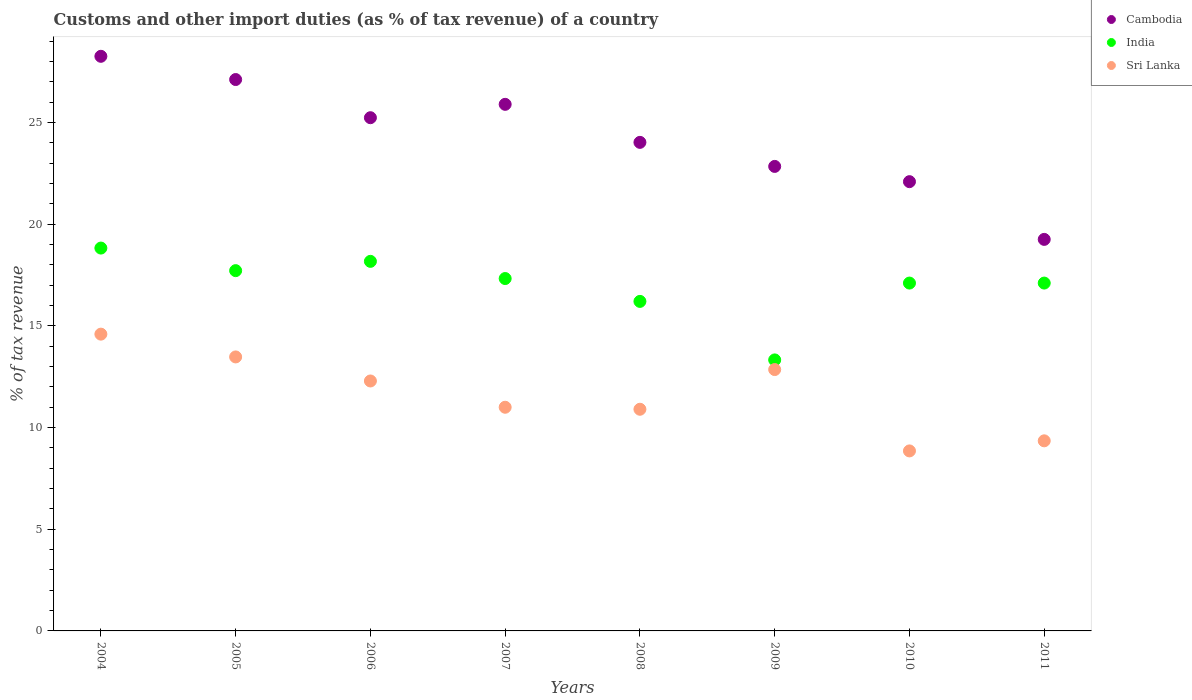What is the percentage of tax revenue from customs in Cambodia in 2008?
Offer a very short reply. 24.03. Across all years, what is the maximum percentage of tax revenue from customs in India?
Keep it short and to the point. 18.83. Across all years, what is the minimum percentage of tax revenue from customs in India?
Ensure brevity in your answer.  13.33. In which year was the percentage of tax revenue from customs in Sri Lanka maximum?
Give a very brief answer. 2004. What is the total percentage of tax revenue from customs in Sri Lanka in the graph?
Offer a very short reply. 93.32. What is the difference between the percentage of tax revenue from customs in Sri Lanka in 2005 and that in 2009?
Your answer should be compact. 0.62. What is the difference between the percentage of tax revenue from customs in India in 2006 and the percentage of tax revenue from customs in Sri Lanka in 2008?
Keep it short and to the point. 7.27. What is the average percentage of tax revenue from customs in India per year?
Your response must be concise. 16.98. In the year 2004, what is the difference between the percentage of tax revenue from customs in Sri Lanka and percentage of tax revenue from customs in India?
Your response must be concise. -4.23. In how many years, is the percentage of tax revenue from customs in India greater than 28 %?
Your answer should be very brief. 0. What is the ratio of the percentage of tax revenue from customs in Sri Lanka in 2004 to that in 2008?
Your answer should be very brief. 1.34. Is the percentage of tax revenue from customs in Cambodia in 2008 less than that in 2011?
Offer a terse response. No. Is the difference between the percentage of tax revenue from customs in Sri Lanka in 2004 and 2005 greater than the difference between the percentage of tax revenue from customs in India in 2004 and 2005?
Offer a terse response. Yes. What is the difference between the highest and the second highest percentage of tax revenue from customs in Sri Lanka?
Give a very brief answer. 1.12. What is the difference between the highest and the lowest percentage of tax revenue from customs in Sri Lanka?
Your response must be concise. 5.74. In how many years, is the percentage of tax revenue from customs in India greater than the average percentage of tax revenue from customs in India taken over all years?
Keep it short and to the point. 6. Is the sum of the percentage of tax revenue from customs in Cambodia in 2010 and 2011 greater than the maximum percentage of tax revenue from customs in Sri Lanka across all years?
Your answer should be very brief. Yes. Is it the case that in every year, the sum of the percentage of tax revenue from customs in Cambodia and percentage of tax revenue from customs in India  is greater than the percentage of tax revenue from customs in Sri Lanka?
Ensure brevity in your answer.  Yes. Does the percentage of tax revenue from customs in Sri Lanka monotonically increase over the years?
Offer a terse response. No. Is the percentage of tax revenue from customs in Sri Lanka strictly less than the percentage of tax revenue from customs in Cambodia over the years?
Your answer should be very brief. Yes. How many years are there in the graph?
Your answer should be very brief. 8. What is the difference between two consecutive major ticks on the Y-axis?
Provide a succinct answer. 5. Are the values on the major ticks of Y-axis written in scientific E-notation?
Offer a terse response. No. Does the graph contain any zero values?
Offer a very short reply. No. Where does the legend appear in the graph?
Provide a short and direct response. Top right. How many legend labels are there?
Give a very brief answer. 3. How are the legend labels stacked?
Your response must be concise. Vertical. What is the title of the graph?
Give a very brief answer. Customs and other import duties (as % of tax revenue) of a country. Does "Guam" appear as one of the legend labels in the graph?
Give a very brief answer. No. What is the label or title of the Y-axis?
Provide a short and direct response. % of tax revenue. What is the % of tax revenue of Cambodia in 2004?
Keep it short and to the point. 28.26. What is the % of tax revenue of India in 2004?
Your answer should be very brief. 18.83. What is the % of tax revenue of Sri Lanka in 2004?
Provide a succinct answer. 14.6. What is the % of tax revenue of Cambodia in 2005?
Offer a very short reply. 27.12. What is the % of tax revenue in India in 2005?
Your answer should be very brief. 17.72. What is the % of tax revenue in Sri Lanka in 2005?
Offer a terse response. 13.48. What is the % of tax revenue of Cambodia in 2006?
Your response must be concise. 25.24. What is the % of tax revenue of India in 2006?
Ensure brevity in your answer.  18.18. What is the % of tax revenue of Sri Lanka in 2006?
Give a very brief answer. 12.29. What is the % of tax revenue of Cambodia in 2007?
Keep it short and to the point. 25.9. What is the % of tax revenue in India in 2007?
Ensure brevity in your answer.  17.33. What is the % of tax revenue of Sri Lanka in 2007?
Make the answer very short. 11. What is the % of tax revenue of Cambodia in 2008?
Offer a very short reply. 24.03. What is the % of tax revenue of India in 2008?
Your answer should be compact. 16.21. What is the % of tax revenue of Sri Lanka in 2008?
Provide a short and direct response. 10.9. What is the % of tax revenue in Cambodia in 2009?
Make the answer very short. 22.85. What is the % of tax revenue of India in 2009?
Your response must be concise. 13.33. What is the % of tax revenue of Sri Lanka in 2009?
Your answer should be compact. 12.85. What is the % of tax revenue in Cambodia in 2010?
Ensure brevity in your answer.  22.1. What is the % of tax revenue of India in 2010?
Your answer should be very brief. 17.11. What is the % of tax revenue in Sri Lanka in 2010?
Offer a terse response. 8.85. What is the % of tax revenue in Cambodia in 2011?
Offer a very short reply. 19.26. What is the % of tax revenue of India in 2011?
Ensure brevity in your answer.  17.11. What is the % of tax revenue in Sri Lanka in 2011?
Keep it short and to the point. 9.35. Across all years, what is the maximum % of tax revenue of Cambodia?
Your answer should be compact. 28.26. Across all years, what is the maximum % of tax revenue in India?
Provide a short and direct response. 18.83. Across all years, what is the maximum % of tax revenue in Sri Lanka?
Provide a short and direct response. 14.6. Across all years, what is the minimum % of tax revenue in Cambodia?
Your answer should be very brief. 19.26. Across all years, what is the minimum % of tax revenue in India?
Offer a very short reply. 13.33. Across all years, what is the minimum % of tax revenue in Sri Lanka?
Provide a succinct answer. 8.85. What is the total % of tax revenue of Cambodia in the graph?
Ensure brevity in your answer.  194.75. What is the total % of tax revenue in India in the graph?
Give a very brief answer. 135.81. What is the total % of tax revenue in Sri Lanka in the graph?
Your answer should be very brief. 93.32. What is the difference between the % of tax revenue of Cambodia in 2004 and that in 2005?
Provide a succinct answer. 1.14. What is the difference between the % of tax revenue in India in 2004 and that in 2005?
Your response must be concise. 1.11. What is the difference between the % of tax revenue of Sri Lanka in 2004 and that in 2005?
Your answer should be compact. 1.12. What is the difference between the % of tax revenue in Cambodia in 2004 and that in 2006?
Provide a succinct answer. 3.02. What is the difference between the % of tax revenue of India in 2004 and that in 2006?
Your response must be concise. 0.65. What is the difference between the % of tax revenue of Sri Lanka in 2004 and that in 2006?
Provide a succinct answer. 2.3. What is the difference between the % of tax revenue of Cambodia in 2004 and that in 2007?
Provide a short and direct response. 2.36. What is the difference between the % of tax revenue of India in 2004 and that in 2007?
Give a very brief answer. 1.5. What is the difference between the % of tax revenue of Sri Lanka in 2004 and that in 2007?
Offer a terse response. 3.6. What is the difference between the % of tax revenue of Cambodia in 2004 and that in 2008?
Your answer should be very brief. 4.23. What is the difference between the % of tax revenue in India in 2004 and that in 2008?
Offer a very short reply. 2.62. What is the difference between the % of tax revenue in Sri Lanka in 2004 and that in 2008?
Keep it short and to the point. 3.69. What is the difference between the % of tax revenue of Cambodia in 2004 and that in 2009?
Make the answer very short. 5.42. What is the difference between the % of tax revenue in India in 2004 and that in 2009?
Ensure brevity in your answer.  5.5. What is the difference between the % of tax revenue of Sri Lanka in 2004 and that in 2009?
Provide a succinct answer. 1.74. What is the difference between the % of tax revenue of Cambodia in 2004 and that in 2010?
Your answer should be very brief. 6.17. What is the difference between the % of tax revenue of India in 2004 and that in 2010?
Give a very brief answer. 1.72. What is the difference between the % of tax revenue in Sri Lanka in 2004 and that in 2010?
Offer a very short reply. 5.74. What is the difference between the % of tax revenue of Cambodia in 2004 and that in 2011?
Provide a short and direct response. 9. What is the difference between the % of tax revenue in India in 2004 and that in 2011?
Keep it short and to the point. 1.72. What is the difference between the % of tax revenue of Sri Lanka in 2004 and that in 2011?
Your answer should be compact. 5.25. What is the difference between the % of tax revenue of Cambodia in 2005 and that in 2006?
Keep it short and to the point. 1.88. What is the difference between the % of tax revenue in India in 2005 and that in 2006?
Give a very brief answer. -0.46. What is the difference between the % of tax revenue of Sri Lanka in 2005 and that in 2006?
Ensure brevity in your answer.  1.18. What is the difference between the % of tax revenue in Cambodia in 2005 and that in 2007?
Keep it short and to the point. 1.22. What is the difference between the % of tax revenue of India in 2005 and that in 2007?
Provide a succinct answer. 0.39. What is the difference between the % of tax revenue of Sri Lanka in 2005 and that in 2007?
Keep it short and to the point. 2.48. What is the difference between the % of tax revenue of Cambodia in 2005 and that in 2008?
Give a very brief answer. 3.09. What is the difference between the % of tax revenue of India in 2005 and that in 2008?
Offer a terse response. 1.51. What is the difference between the % of tax revenue of Sri Lanka in 2005 and that in 2008?
Your answer should be very brief. 2.57. What is the difference between the % of tax revenue of Cambodia in 2005 and that in 2009?
Offer a terse response. 4.27. What is the difference between the % of tax revenue of India in 2005 and that in 2009?
Provide a short and direct response. 4.39. What is the difference between the % of tax revenue in Sri Lanka in 2005 and that in 2009?
Offer a terse response. 0.62. What is the difference between the % of tax revenue in Cambodia in 2005 and that in 2010?
Ensure brevity in your answer.  5.02. What is the difference between the % of tax revenue in India in 2005 and that in 2010?
Make the answer very short. 0.61. What is the difference between the % of tax revenue in Sri Lanka in 2005 and that in 2010?
Your response must be concise. 4.62. What is the difference between the % of tax revenue in Cambodia in 2005 and that in 2011?
Provide a succinct answer. 7.86. What is the difference between the % of tax revenue of India in 2005 and that in 2011?
Make the answer very short. 0.61. What is the difference between the % of tax revenue of Sri Lanka in 2005 and that in 2011?
Provide a short and direct response. 4.13. What is the difference between the % of tax revenue of Cambodia in 2006 and that in 2007?
Offer a very short reply. -0.66. What is the difference between the % of tax revenue of India in 2006 and that in 2007?
Keep it short and to the point. 0.85. What is the difference between the % of tax revenue of Sri Lanka in 2006 and that in 2007?
Provide a succinct answer. 1.29. What is the difference between the % of tax revenue in Cambodia in 2006 and that in 2008?
Offer a terse response. 1.21. What is the difference between the % of tax revenue in India in 2006 and that in 2008?
Your answer should be very brief. 1.97. What is the difference between the % of tax revenue in Sri Lanka in 2006 and that in 2008?
Your response must be concise. 1.39. What is the difference between the % of tax revenue in Cambodia in 2006 and that in 2009?
Give a very brief answer. 2.4. What is the difference between the % of tax revenue in India in 2006 and that in 2009?
Ensure brevity in your answer.  4.85. What is the difference between the % of tax revenue of Sri Lanka in 2006 and that in 2009?
Offer a very short reply. -0.56. What is the difference between the % of tax revenue of Cambodia in 2006 and that in 2010?
Your response must be concise. 3.15. What is the difference between the % of tax revenue of India in 2006 and that in 2010?
Offer a very short reply. 1.07. What is the difference between the % of tax revenue in Sri Lanka in 2006 and that in 2010?
Keep it short and to the point. 3.44. What is the difference between the % of tax revenue of Cambodia in 2006 and that in 2011?
Your answer should be very brief. 5.98. What is the difference between the % of tax revenue in India in 2006 and that in 2011?
Give a very brief answer. 1.07. What is the difference between the % of tax revenue in Sri Lanka in 2006 and that in 2011?
Your response must be concise. 2.94. What is the difference between the % of tax revenue of Cambodia in 2007 and that in 2008?
Your answer should be compact. 1.87. What is the difference between the % of tax revenue of India in 2007 and that in 2008?
Your answer should be compact. 1.12. What is the difference between the % of tax revenue in Sri Lanka in 2007 and that in 2008?
Keep it short and to the point. 0.1. What is the difference between the % of tax revenue in Cambodia in 2007 and that in 2009?
Offer a terse response. 3.05. What is the difference between the % of tax revenue of India in 2007 and that in 2009?
Offer a very short reply. 4. What is the difference between the % of tax revenue in Sri Lanka in 2007 and that in 2009?
Ensure brevity in your answer.  -1.85. What is the difference between the % of tax revenue of Cambodia in 2007 and that in 2010?
Give a very brief answer. 3.8. What is the difference between the % of tax revenue in India in 2007 and that in 2010?
Your answer should be compact. 0.22. What is the difference between the % of tax revenue in Sri Lanka in 2007 and that in 2010?
Your answer should be compact. 2.15. What is the difference between the % of tax revenue in Cambodia in 2007 and that in 2011?
Provide a succinct answer. 6.64. What is the difference between the % of tax revenue in India in 2007 and that in 2011?
Your response must be concise. 0.22. What is the difference between the % of tax revenue in Sri Lanka in 2007 and that in 2011?
Your answer should be very brief. 1.65. What is the difference between the % of tax revenue of Cambodia in 2008 and that in 2009?
Your response must be concise. 1.18. What is the difference between the % of tax revenue in India in 2008 and that in 2009?
Your response must be concise. 2.88. What is the difference between the % of tax revenue in Sri Lanka in 2008 and that in 2009?
Offer a terse response. -1.95. What is the difference between the % of tax revenue of Cambodia in 2008 and that in 2010?
Offer a terse response. 1.93. What is the difference between the % of tax revenue of India in 2008 and that in 2010?
Provide a succinct answer. -0.9. What is the difference between the % of tax revenue of Sri Lanka in 2008 and that in 2010?
Give a very brief answer. 2.05. What is the difference between the % of tax revenue of Cambodia in 2008 and that in 2011?
Provide a short and direct response. 4.77. What is the difference between the % of tax revenue of India in 2008 and that in 2011?
Provide a short and direct response. -0.9. What is the difference between the % of tax revenue in Sri Lanka in 2008 and that in 2011?
Offer a very short reply. 1.55. What is the difference between the % of tax revenue in Cambodia in 2009 and that in 2010?
Provide a short and direct response. 0.75. What is the difference between the % of tax revenue in India in 2009 and that in 2010?
Give a very brief answer. -3.78. What is the difference between the % of tax revenue in Sri Lanka in 2009 and that in 2010?
Your answer should be compact. 4. What is the difference between the % of tax revenue in Cambodia in 2009 and that in 2011?
Your answer should be compact. 3.59. What is the difference between the % of tax revenue of India in 2009 and that in 2011?
Give a very brief answer. -3.78. What is the difference between the % of tax revenue in Sri Lanka in 2009 and that in 2011?
Provide a short and direct response. 3.5. What is the difference between the % of tax revenue of Cambodia in 2010 and that in 2011?
Provide a succinct answer. 2.84. What is the difference between the % of tax revenue in India in 2010 and that in 2011?
Provide a succinct answer. 0. What is the difference between the % of tax revenue in Sri Lanka in 2010 and that in 2011?
Ensure brevity in your answer.  -0.5. What is the difference between the % of tax revenue of Cambodia in 2004 and the % of tax revenue of India in 2005?
Provide a succinct answer. 10.54. What is the difference between the % of tax revenue in Cambodia in 2004 and the % of tax revenue in Sri Lanka in 2005?
Offer a very short reply. 14.79. What is the difference between the % of tax revenue in India in 2004 and the % of tax revenue in Sri Lanka in 2005?
Provide a succinct answer. 5.35. What is the difference between the % of tax revenue of Cambodia in 2004 and the % of tax revenue of India in 2006?
Your response must be concise. 10.08. What is the difference between the % of tax revenue of Cambodia in 2004 and the % of tax revenue of Sri Lanka in 2006?
Keep it short and to the point. 15.97. What is the difference between the % of tax revenue of India in 2004 and the % of tax revenue of Sri Lanka in 2006?
Provide a short and direct response. 6.54. What is the difference between the % of tax revenue of Cambodia in 2004 and the % of tax revenue of India in 2007?
Provide a succinct answer. 10.93. What is the difference between the % of tax revenue in Cambodia in 2004 and the % of tax revenue in Sri Lanka in 2007?
Provide a short and direct response. 17.26. What is the difference between the % of tax revenue in India in 2004 and the % of tax revenue in Sri Lanka in 2007?
Offer a terse response. 7.83. What is the difference between the % of tax revenue of Cambodia in 2004 and the % of tax revenue of India in 2008?
Make the answer very short. 12.05. What is the difference between the % of tax revenue in Cambodia in 2004 and the % of tax revenue in Sri Lanka in 2008?
Keep it short and to the point. 17.36. What is the difference between the % of tax revenue in India in 2004 and the % of tax revenue in Sri Lanka in 2008?
Keep it short and to the point. 7.93. What is the difference between the % of tax revenue of Cambodia in 2004 and the % of tax revenue of India in 2009?
Offer a very short reply. 14.93. What is the difference between the % of tax revenue of Cambodia in 2004 and the % of tax revenue of Sri Lanka in 2009?
Your answer should be very brief. 15.41. What is the difference between the % of tax revenue in India in 2004 and the % of tax revenue in Sri Lanka in 2009?
Your answer should be very brief. 5.98. What is the difference between the % of tax revenue of Cambodia in 2004 and the % of tax revenue of India in 2010?
Give a very brief answer. 11.15. What is the difference between the % of tax revenue of Cambodia in 2004 and the % of tax revenue of Sri Lanka in 2010?
Give a very brief answer. 19.41. What is the difference between the % of tax revenue of India in 2004 and the % of tax revenue of Sri Lanka in 2010?
Offer a terse response. 9.98. What is the difference between the % of tax revenue of Cambodia in 2004 and the % of tax revenue of India in 2011?
Your answer should be very brief. 11.15. What is the difference between the % of tax revenue of Cambodia in 2004 and the % of tax revenue of Sri Lanka in 2011?
Ensure brevity in your answer.  18.91. What is the difference between the % of tax revenue of India in 2004 and the % of tax revenue of Sri Lanka in 2011?
Offer a very short reply. 9.48. What is the difference between the % of tax revenue in Cambodia in 2005 and the % of tax revenue in India in 2006?
Your answer should be compact. 8.94. What is the difference between the % of tax revenue of Cambodia in 2005 and the % of tax revenue of Sri Lanka in 2006?
Provide a succinct answer. 14.83. What is the difference between the % of tax revenue of India in 2005 and the % of tax revenue of Sri Lanka in 2006?
Provide a short and direct response. 5.43. What is the difference between the % of tax revenue in Cambodia in 2005 and the % of tax revenue in India in 2007?
Offer a very short reply. 9.79. What is the difference between the % of tax revenue in Cambodia in 2005 and the % of tax revenue in Sri Lanka in 2007?
Your answer should be very brief. 16.12. What is the difference between the % of tax revenue in India in 2005 and the % of tax revenue in Sri Lanka in 2007?
Your response must be concise. 6.72. What is the difference between the % of tax revenue of Cambodia in 2005 and the % of tax revenue of India in 2008?
Offer a terse response. 10.91. What is the difference between the % of tax revenue in Cambodia in 2005 and the % of tax revenue in Sri Lanka in 2008?
Give a very brief answer. 16.22. What is the difference between the % of tax revenue in India in 2005 and the % of tax revenue in Sri Lanka in 2008?
Your response must be concise. 6.82. What is the difference between the % of tax revenue of Cambodia in 2005 and the % of tax revenue of India in 2009?
Provide a succinct answer. 13.79. What is the difference between the % of tax revenue in Cambodia in 2005 and the % of tax revenue in Sri Lanka in 2009?
Offer a terse response. 14.26. What is the difference between the % of tax revenue of India in 2005 and the % of tax revenue of Sri Lanka in 2009?
Make the answer very short. 4.87. What is the difference between the % of tax revenue of Cambodia in 2005 and the % of tax revenue of India in 2010?
Offer a very short reply. 10.01. What is the difference between the % of tax revenue of Cambodia in 2005 and the % of tax revenue of Sri Lanka in 2010?
Make the answer very short. 18.27. What is the difference between the % of tax revenue of India in 2005 and the % of tax revenue of Sri Lanka in 2010?
Your answer should be very brief. 8.87. What is the difference between the % of tax revenue in Cambodia in 2005 and the % of tax revenue in India in 2011?
Give a very brief answer. 10.01. What is the difference between the % of tax revenue of Cambodia in 2005 and the % of tax revenue of Sri Lanka in 2011?
Your answer should be very brief. 17.77. What is the difference between the % of tax revenue of India in 2005 and the % of tax revenue of Sri Lanka in 2011?
Your response must be concise. 8.37. What is the difference between the % of tax revenue in Cambodia in 2006 and the % of tax revenue in India in 2007?
Provide a short and direct response. 7.91. What is the difference between the % of tax revenue in Cambodia in 2006 and the % of tax revenue in Sri Lanka in 2007?
Your answer should be very brief. 14.24. What is the difference between the % of tax revenue in India in 2006 and the % of tax revenue in Sri Lanka in 2007?
Your answer should be very brief. 7.18. What is the difference between the % of tax revenue of Cambodia in 2006 and the % of tax revenue of India in 2008?
Your answer should be very brief. 9.03. What is the difference between the % of tax revenue of Cambodia in 2006 and the % of tax revenue of Sri Lanka in 2008?
Ensure brevity in your answer.  14.34. What is the difference between the % of tax revenue in India in 2006 and the % of tax revenue in Sri Lanka in 2008?
Keep it short and to the point. 7.27. What is the difference between the % of tax revenue in Cambodia in 2006 and the % of tax revenue in India in 2009?
Offer a terse response. 11.91. What is the difference between the % of tax revenue of Cambodia in 2006 and the % of tax revenue of Sri Lanka in 2009?
Provide a short and direct response. 12.39. What is the difference between the % of tax revenue in India in 2006 and the % of tax revenue in Sri Lanka in 2009?
Provide a short and direct response. 5.32. What is the difference between the % of tax revenue of Cambodia in 2006 and the % of tax revenue of India in 2010?
Your answer should be compact. 8.13. What is the difference between the % of tax revenue of Cambodia in 2006 and the % of tax revenue of Sri Lanka in 2010?
Provide a short and direct response. 16.39. What is the difference between the % of tax revenue of India in 2006 and the % of tax revenue of Sri Lanka in 2010?
Offer a terse response. 9.32. What is the difference between the % of tax revenue of Cambodia in 2006 and the % of tax revenue of India in 2011?
Provide a short and direct response. 8.13. What is the difference between the % of tax revenue in Cambodia in 2006 and the % of tax revenue in Sri Lanka in 2011?
Offer a terse response. 15.89. What is the difference between the % of tax revenue of India in 2006 and the % of tax revenue of Sri Lanka in 2011?
Your response must be concise. 8.83. What is the difference between the % of tax revenue in Cambodia in 2007 and the % of tax revenue in India in 2008?
Your answer should be very brief. 9.69. What is the difference between the % of tax revenue in Cambodia in 2007 and the % of tax revenue in Sri Lanka in 2008?
Your answer should be very brief. 15. What is the difference between the % of tax revenue in India in 2007 and the % of tax revenue in Sri Lanka in 2008?
Make the answer very short. 6.43. What is the difference between the % of tax revenue in Cambodia in 2007 and the % of tax revenue in India in 2009?
Your response must be concise. 12.57. What is the difference between the % of tax revenue in Cambodia in 2007 and the % of tax revenue in Sri Lanka in 2009?
Keep it short and to the point. 13.04. What is the difference between the % of tax revenue of India in 2007 and the % of tax revenue of Sri Lanka in 2009?
Ensure brevity in your answer.  4.48. What is the difference between the % of tax revenue in Cambodia in 2007 and the % of tax revenue in India in 2010?
Give a very brief answer. 8.79. What is the difference between the % of tax revenue in Cambodia in 2007 and the % of tax revenue in Sri Lanka in 2010?
Provide a short and direct response. 17.05. What is the difference between the % of tax revenue of India in 2007 and the % of tax revenue of Sri Lanka in 2010?
Offer a terse response. 8.48. What is the difference between the % of tax revenue in Cambodia in 2007 and the % of tax revenue in India in 2011?
Your response must be concise. 8.79. What is the difference between the % of tax revenue of Cambodia in 2007 and the % of tax revenue of Sri Lanka in 2011?
Ensure brevity in your answer.  16.55. What is the difference between the % of tax revenue of India in 2007 and the % of tax revenue of Sri Lanka in 2011?
Offer a very short reply. 7.98. What is the difference between the % of tax revenue of Cambodia in 2008 and the % of tax revenue of India in 2009?
Your answer should be compact. 10.7. What is the difference between the % of tax revenue in Cambodia in 2008 and the % of tax revenue in Sri Lanka in 2009?
Your answer should be compact. 11.17. What is the difference between the % of tax revenue of India in 2008 and the % of tax revenue of Sri Lanka in 2009?
Your answer should be compact. 3.35. What is the difference between the % of tax revenue in Cambodia in 2008 and the % of tax revenue in India in 2010?
Keep it short and to the point. 6.92. What is the difference between the % of tax revenue of Cambodia in 2008 and the % of tax revenue of Sri Lanka in 2010?
Give a very brief answer. 15.18. What is the difference between the % of tax revenue in India in 2008 and the % of tax revenue in Sri Lanka in 2010?
Offer a terse response. 7.35. What is the difference between the % of tax revenue in Cambodia in 2008 and the % of tax revenue in India in 2011?
Keep it short and to the point. 6.92. What is the difference between the % of tax revenue in Cambodia in 2008 and the % of tax revenue in Sri Lanka in 2011?
Your answer should be compact. 14.68. What is the difference between the % of tax revenue of India in 2008 and the % of tax revenue of Sri Lanka in 2011?
Your response must be concise. 6.86. What is the difference between the % of tax revenue in Cambodia in 2009 and the % of tax revenue in India in 2010?
Offer a terse response. 5.74. What is the difference between the % of tax revenue in Cambodia in 2009 and the % of tax revenue in Sri Lanka in 2010?
Provide a succinct answer. 13.99. What is the difference between the % of tax revenue in India in 2009 and the % of tax revenue in Sri Lanka in 2010?
Offer a very short reply. 4.48. What is the difference between the % of tax revenue of Cambodia in 2009 and the % of tax revenue of India in 2011?
Keep it short and to the point. 5.74. What is the difference between the % of tax revenue in Cambodia in 2009 and the % of tax revenue in Sri Lanka in 2011?
Offer a very short reply. 13.5. What is the difference between the % of tax revenue of India in 2009 and the % of tax revenue of Sri Lanka in 2011?
Offer a terse response. 3.98. What is the difference between the % of tax revenue in Cambodia in 2010 and the % of tax revenue in India in 2011?
Your response must be concise. 4.99. What is the difference between the % of tax revenue in Cambodia in 2010 and the % of tax revenue in Sri Lanka in 2011?
Your answer should be very brief. 12.75. What is the difference between the % of tax revenue in India in 2010 and the % of tax revenue in Sri Lanka in 2011?
Provide a succinct answer. 7.76. What is the average % of tax revenue in Cambodia per year?
Make the answer very short. 24.34. What is the average % of tax revenue in India per year?
Ensure brevity in your answer.  16.98. What is the average % of tax revenue in Sri Lanka per year?
Give a very brief answer. 11.67. In the year 2004, what is the difference between the % of tax revenue in Cambodia and % of tax revenue in India?
Give a very brief answer. 9.43. In the year 2004, what is the difference between the % of tax revenue in Cambodia and % of tax revenue in Sri Lanka?
Provide a short and direct response. 13.66. In the year 2004, what is the difference between the % of tax revenue of India and % of tax revenue of Sri Lanka?
Keep it short and to the point. 4.23. In the year 2005, what is the difference between the % of tax revenue of Cambodia and % of tax revenue of India?
Your answer should be very brief. 9.4. In the year 2005, what is the difference between the % of tax revenue of Cambodia and % of tax revenue of Sri Lanka?
Your answer should be compact. 13.64. In the year 2005, what is the difference between the % of tax revenue of India and % of tax revenue of Sri Lanka?
Your response must be concise. 4.24. In the year 2006, what is the difference between the % of tax revenue in Cambodia and % of tax revenue in India?
Give a very brief answer. 7.07. In the year 2006, what is the difference between the % of tax revenue of Cambodia and % of tax revenue of Sri Lanka?
Make the answer very short. 12.95. In the year 2006, what is the difference between the % of tax revenue of India and % of tax revenue of Sri Lanka?
Keep it short and to the point. 5.88. In the year 2007, what is the difference between the % of tax revenue of Cambodia and % of tax revenue of India?
Ensure brevity in your answer.  8.57. In the year 2007, what is the difference between the % of tax revenue in Cambodia and % of tax revenue in Sri Lanka?
Keep it short and to the point. 14.9. In the year 2007, what is the difference between the % of tax revenue of India and % of tax revenue of Sri Lanka?
Provide a short and direct response. 6.33. In the year 2008, what is the difference between the % of tax revenue of Cambodia and % of tax revenue of India?
Keep it short and to the point. 7.82. In the year 2008, what is the difference between the % of tax revenue of Cambodia and % of tax revenue of Sri Lanka?
Your answer should be compact. 13.13. In the year 2008, what is the difference between the % of tax revenue in India and % of tax revenue in Sri Lanka?
Offer a terse response. 5.3. In the year 2009, what is the difference between the % of tax revenue of Cambodia and % of tax revenue of India?
Your response must be concise. 9.52. In the year 2009, what is the difference between the % of tax revenue in Cambodia and % of tax revenue in Sri Lanka?
Offer a terse response. 9.99. In the year 2009, what is the difference between the % of tax revenue of India and % of tax revenue of Sri Lanka?
Provide a short and direct response. 0.47. In the year 2010, what is the difference between the % of tax revenue in Cambodia and % of tax revenue in India?
Ensure brevity in your answer.  4.99. In the year 2010, what is the difference between the % of tax revenue of Cambodia and % of tax revenue of Sri Lanka?
Your response must be concise. 13.24. In the year 2010, what is the difference between the % of tax revenue of India and % of tax revenue of Sri Lanka?
Offer a very short reply. 8.26. In the year 2011, what is the difference between the % of tax revenue in Cambodia and % of tax revenue in India?
Provide a short and direct response. 2.15. In the year 2011, what is the difference between the % of tax revenue in Cambodia and % of tax revenue in Sri Lanka?
Your response must be concise. 9.91. In the year 2011, what is the difference between the % of tax revenue in India and % of tax revenue in Sri Lanka?
Ensure brevity in your answer.  7.76. What is the ratio of the % of tax revenue in Cambodia in 2004 to that in 2005?
Your answer should be very brief. 1.04. What is the ratio of the % of tax revenue in India in 2004 to that in 2005?
Keep it short and to the point. 1.06. What is the ratio of the % of tax revenue in Sri Lanka in 2004 to that in 2005?
Keep it short and to the point. 1.08. What is the ratio of the % of tax revenue in Cambodia in 2004 to that in 2006?
Make the answer very short. 1.12. What is the ratio of the % of tax revenue in India in 2004 to that in 2006?
Give a very brief answer. 1.04. What is the ratio of the % of tax revenue of Sri Lanka in 2004 to that in 2006?
Offer a terse response. 1.19. What is the ratio of the % of tax revenue in Cambodia in 2004 to that in 2007?
Offer a very short reply. 1.09. What is the ratio of the % of tax revenue of India in 2004 to that in 2007?
Offer a very short reply. 1.09. What is the ratio of the % of tax revenue in Sri Lanka in 2004 to that in 2007?
Your response must be concise. 1.33. What is the ratio of the % of tax revenue in Cambodia in 2004 to that in 2008?
Give a very brief answer. 1.18. What is the ratio of the % of tax revenue in India in 2004 to that in 2008?
Offer a very short reply. 1.16. What is the ratio of the % of tax revenue of Sri Lanka in 2004 to that in 2008?
Your answer should be very brief. 1.34. What is the ratio of the % of tax revenue in Cambodia in 2004 to that in 2009?
Make the answer very short. 1.24. What is the ratio of the % of tax revenue in India in 2004 to that in 2009?
Keep it short and to the point. 1.41. What is the ratio of the % of tax revenue in Sri Lanka in 2004 to that in 2009?
Offer a very short reply. 1.14. What is the ratio of the % of tax revenue of Cambodia in 2004 to that in 2010?
Your response must be concise. 1.28. What is the ratio of the % of tax revenue in India in 2004 to that in 2010?
Offer a terse response. 1.1. What is the ratio of the % of tax revenue of Sri Lanka in 2004 to that in 2010?
Provide a succinct answer. 1.65. What is the ratio of the % of tax revenue in Cambodia in 2004 to that in 2011?
Your answer should be compact. 1.47. What is the ratio of the % of tax revenue in India in 2004 to that in 2011?
Make the answer very short. 1.1. What is the ratio of the % of tax revenue in Sri Lanka in 2004 to that in 2011?
Provide a short and direct response. 1.56. What is the ratio of the % of tax revenue in Cambodia in 2005 to that in 2006?
Your answer should be compact. 1.07. What is the ratio of the % of tax revenue of India in 2005 to that in 2006?
Offer a terse response. 0.97. What is the ratio of the % of tax revenue in Sri Lanka in 2005 to that in 2006?
Offer a very short reply. 1.1. What is the ratio of the % of tax revenue in Cambodia in 2005 to that in 2007?
Ensure brevity in your answer.  1.05. What is the ratio of the % of tax revenue of India in 2005 to that in 2007?
Ensure brevity in your answer.  1.02. What is the ratio of the % of tax revenue in Sri Lanka in 2005 to that in 2007?
Your response must be concise. 1.23. What is the ratio of the % of tax revenue in Cambodia in 2005 to that in 2008?
Keep it short and to the point. 1.13. What is the ratio of the % of tax revenue of India in 2005 to that in 2008?
Your answer should be very brief. 1.09. What is the ratio of the % of tax revenue in Sri Lanka in 2005 to that in 2008?
Your response must be concise. 1.24. What is the ratio of the % of tax revenue in Cambodia in 2005 to that in 2009?
Give a very brief answer. 1.19. What is the ratio of the % of tax revenue of India in 2005 to that in 2009?
Offer a very short reply. 1.33. What is the ratio of the % of tax revenue of Sri Lanka in 2005 to that in 2009?
Make the answer very short. 1.05. What is the ratio of the % of tax revenue of Cambodia in 2005 to that in 2010?
Keep it short and to the point. 1.23. What is the ratio of the % of tax revenue of India in 2005 to that in 2010?
Your response must be concise. 1.04. What is the ratio of the % of tax revenue of Sri Lanka in 2005 to that in 2010?
Your response must be concise. 1.52. What is the ratio of the % of tax revenue in Cambodia in 2005 to that in 2011?
Give a very brief answer. 1.41. What is the ratio of the % of tax revenue of India in 2005 to that in 2011?
Provide a short and direct response. 1.04. What is the ratio of the % of tax revenue in Sri Lanka in 2005 to that in 2011?
Your answer should be very brief. 1.44. What is the ratio of the % of tax revenue in Cambodia in 2006 to that in 2007?
Give a very brief answer. 0.97. What is the ratio of the % of tax revenue of India in 2006 to that in 2007?
Your answer should be very brief. 1.05. What is the ratio of the % of tax revenue of Sri Lanka in 2006 to that in 2007?
Your answer should be compact. 1.12. What is the ratio of the % of tax revenue in Cambodia in 2006 to that in 2008?
Offer a very short reply. 1.05. What is the ratio of the % of tax revenue in India in 2006 to that in 2008?
Offer a terse response. 1.12. What is the ratio of the % of tax revenue in Sri Lanka in 2006 to that in 2008?
Offer a terse response. 1.13. What is the ratio of the % of tax revenue in Cambodia in 2006 to that in 2009?
Provide a succinct answer. 1.1. What is the ratio of the % of tax revenue of India in 2006 to that in 2009?
Provide a short and direct response. 1.36. What is the ratio of the % of tax revenue in Sri Lanka in 2006 to that in 2009?
Ensure brevity in your answer.  0.96. What is the ratio of the % of tax revenue in Cambodia in 2006 to that in 2010?
Your answer should be very brief. 1.14. What is the ratio of the % of tax revenue of India in 2006 to that in 2010?
Make the answer very short. 1.06. What is the ratio of the % of tax revenue in Sri Lanka in 2006 to that in 2010?
Give a very brief answer. 1.39. What is the ratio of the % of tax revenue in Cambodia in 2006 to that in 2011?
Keep it short and to the point. 1.31. What is the ratio of the % of tax revenue in India in 2006 to that in 2011?
Provide a short and direct response. 1.06. What is the ratio of the % of tax revenue of Sri Lanka in 2006 to that in 2011?
Keep it short and to the point. 1.31. What is the ratio of the % of tax revenue in Cambodia in 2007 to that in 2008?
Your response must be concise. 1.08. What is the ratio of the % of tax revenue of India in 2007 to that in 2008?
Ensure brevity in your answer.  1.07. What is the ratio of the % of tax revenue of Sri Lanka in 2007 to that in 2008?
Keep it short and to the point. 1.01. What is the ratio of the % of tax revenue in Cambodia in 2007 to that in 2009?
Offer a very short reply. 1.13. What is the ratio of the % of tax revenue of India in 2007 to that in 2009?
Keep it short and to the point. 1.3. What is the ratio of the % of tax revenue in Sri Lanka in 2007 to that in 2009?
Provide a succinct answer. 0.86. What is the ratio of the % of tax revenue of Cambodia in 2007 to that in 2010?
Make the answer very short. 1.17. What is the ratio of the % of tax revenue of Sri Lanka in 2007 to that in 2010?
Your response must be concise. 1.24. What is the ratio of the % of tax revenue of Cambodia in 2007 to that in 2011?
Offer a very short reply. 1.34. What is the ratio of the % of tax revenue in Sri Lanka in 2007 to that in 2011?
Make the answer very short. 1.18. What is the ratio of the % of tax revenue in Cambodia in 2008 to that in 2009?
Your answer should be compact. 1.05. What is the ratio of the % of tax revenue of India in 2008 to that in 2009?
Offer a terse response. 1.22. What is the ratio of the % of tax revenue in Sri Lanka in 2008 to that in 2009?
Your answer should be very brief. 0.85. What is the ratio of the % of tax revenue in Cambodia in 2008 to that in 2010?
Provide a short and direct response. 1.09. What is the ratio of the % of tax revenue of India in 2008 to that in 2010?
Your answer should be compact. 0.95. What is the ratio of the % of tax revenue of Sri Lanka in 2008 to that in 2010?
Give a very brief answer. 1.23. What is the ratio of the % of tax revenue of Cambodia in 2008 to that in 2011?
Your response must be concise. 1.25. What is the ratio of the % of tax revenue of India in 2008 to that in 2011?
Keep it short and to the point. 0.95. What is the ratio of the % of tax revenue of Sri Lanka in 2008 to that in 2011?
Give a very brief answer. 1.17. What is the ratio of the % of tax revenue in Cambodia in 2009 to that in 2010?
Make the answer very short. 1.03. What is the ratio of the % of tax revenue of India in 2009 to that in 2010?
Offer a terse response. 0.78. What is the ratio of the % of tax revenue of Sri Lanka in 2009 to that in 2010?
Ensure brevity in your answer.  1.45. What is the ratio of the % of tax revenue of Cambodia in 2009 to that in 2011?
Make the answer very short. 1.19. What is the ratio of the % of tax revenue of India in 2009 to that in 2011?
Give a very brief answer. 0.78. What is the ratio of the % of tax revenue in Sri Lanka in 2009 to that in 2011?
Your answer should be compact. 1.37. What is the ratio of the % of tax revenue in Cambodia in 2010 to that in 2011?
Your response must be concise. 1.15. What is the ratio of the % of tax revenue in Sri Lanka in 2010 to that in 2011?
Your answer should be compact. 0.95. What is the difference between the highest and the second highest % of tax revenue of Cambodia?
Provide a succinct answer. 1.14. What is the difference between the highest and the second highest % of tax revenue in India?
Your answer should be very brief. 0.65. What is the difference between the highest and the second highest % of tax revenue in Sri Lanka?
Ensure brevity in your answer.  1.12. What is the difference between the highest and the lowest % of tax revenue of Cambodia?
Your answer should be compact. 9. What is the difference between the highest and the lowest % of tax revenue of India?
Keep it short and to the point. 5.5. What is the difference between the highest and the lowest % of tax revenue of Sri Lanka?
Your answer should be very brief. 5.74. 